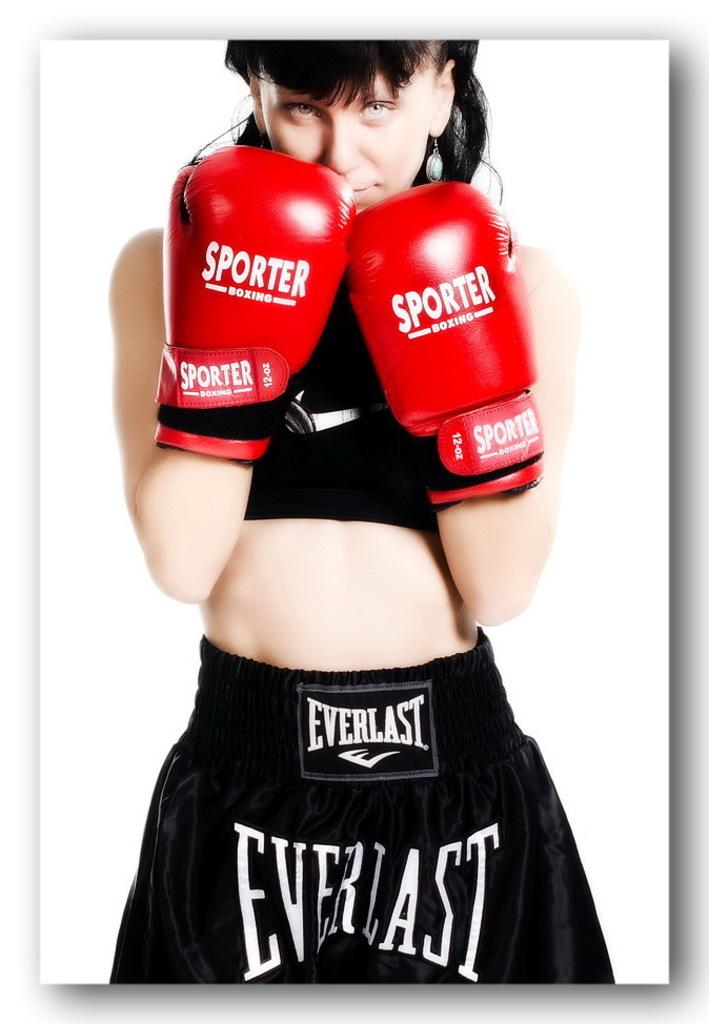<image>
Describe the image concisely. the word Everlast on the side of a person's shorts 